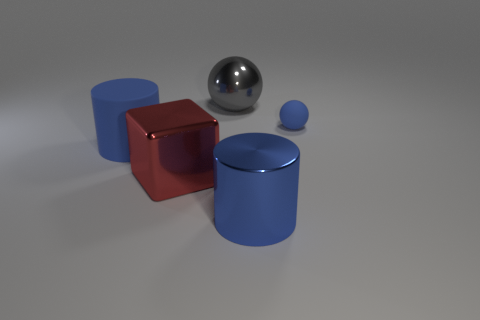What color is the matte cylinder that is the same size as the gray metal ball?
Ensure brevity in your answer.  Blue. Is there a large metallic block of the same color as the big metallic ball?
Give a very brief answer. No. There is a cylinder in front of the big matte thing; is its size the same as the rubber thing that is to the left of the tiny rubber thing?
Your answer should be very brief. Yes. There is a large thing that is right of the large red cube and in front of the gray shiny sphere; what material is it made of?
Provide a short and direct response. Metal. There is a matte cylinder that is the same color as the small thing; what size is it?
Ensure brevity in your answer.  Large. How many other objects are there of the same size as the blue matte ball?
Keep it short and to the point. 0. There is a blue cylinder that is on the left side of the blue shiny thing; what is its material?
Keep it short and to the point. Rubber. Does the gray metallic object have the same shape as the blue shiny object?
Offer a very short reply. No. What number of other objects are the same shape as the tiny blue object?
Offer a very short reply. 1. The big cylinder that is in front of the red metal thing is what color?
Ensure brevity in your answer.  Blue. 